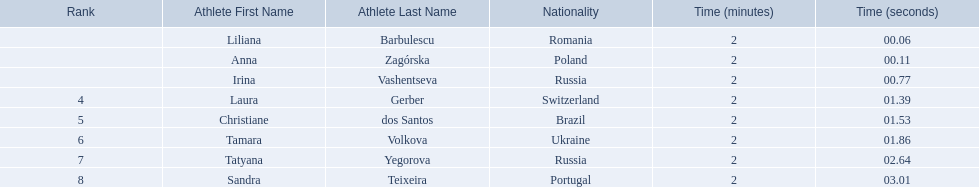What are the names of the competitors? Liliana Barbulescu, Anna Zagórska, Irina Vashentseva, Laura Gerber, Christiane dos Santos, Tamara Volkova, Tatyana Yegorova, Sandra Teixeira. Which finalist finished the fastest? Liliana Barbulescu. Who were the athlete were in the athletics at the 2003 summer universiade - women's 800 metres? , Liliana Barbulescu, Anna Zagórska, Irina Vashentseva, Laura Gerber, Christiane dos Santos, Tamara Volkova, Tatyana Yegorova, Sandra Teixeira. What was anna zagorska finishing time? 2:00.11. 